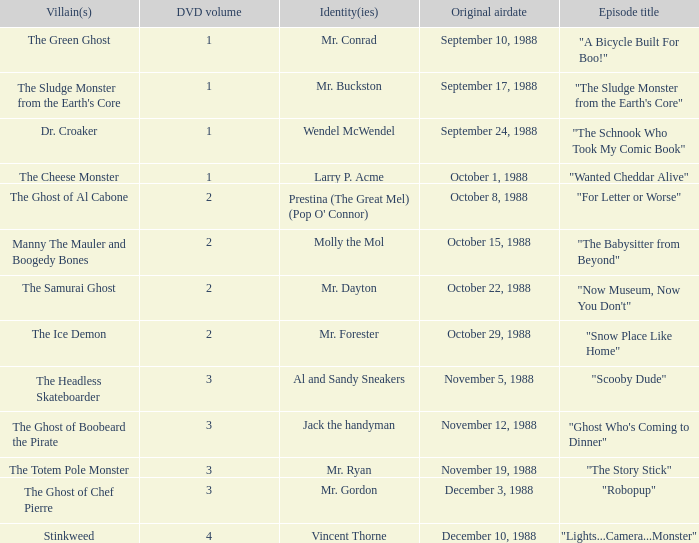Name the original airdate for mr. buckston September 17, 1988. 